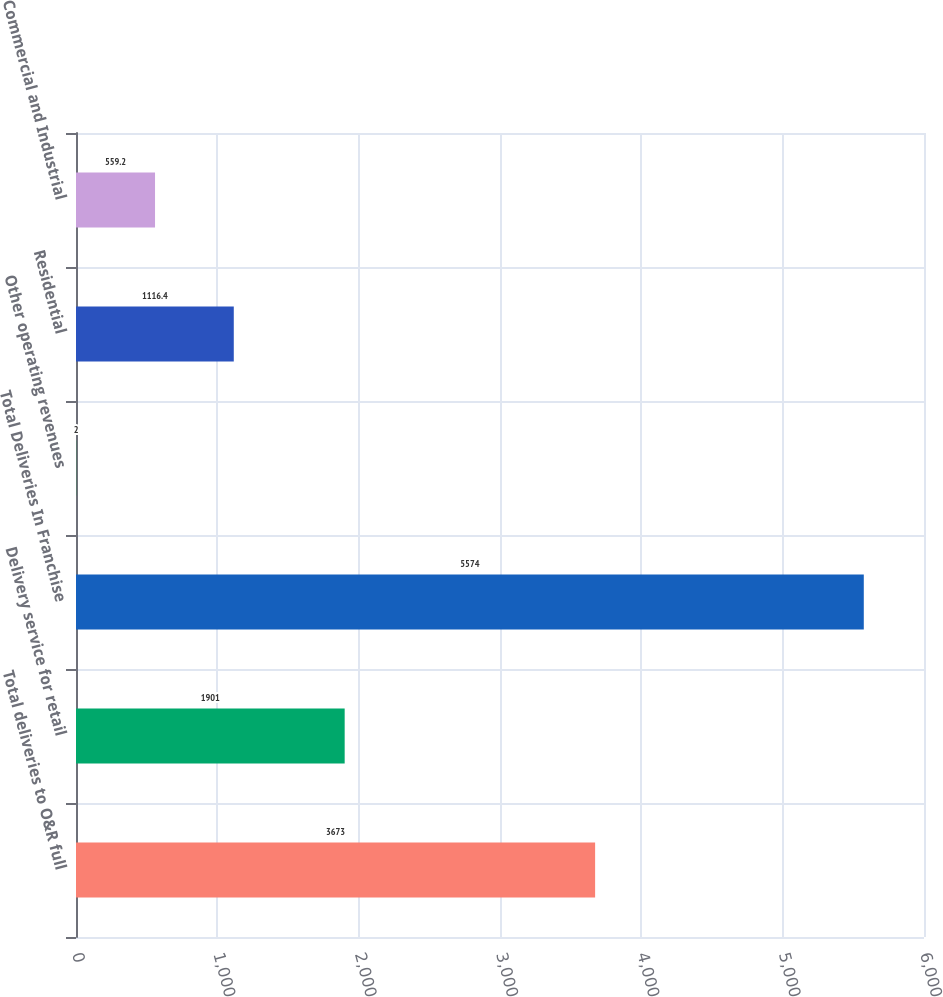Convert chart. <chart><loc_0><loc_0><loc_500><loc_500><bar_chart><fcel>Total deliveries to O&R full<fcel>Delivery service for retail<fcel>Total Deliveries In Franchise<fcel>Other operating revenues<fcel>Residential<fcel>Commercial and Industrial<nl><fcel>3673<fcel>1901<fcel>5574<fcel>2<fcel>1116.4<fcel>559.2<nl></chart> 